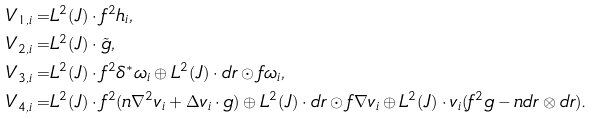Convert formula to latex. <formula><loc_0><loc_0><loc_500><loc_500>V _ { 1 , i } = & L ^ { 2 } ( J ) \cdot f ^ { 2 } h _ { i } , \\ V _ { 2 , i } = & L ^ { 2 } ( J ) \cdot \tilde { g } , \\ V _ { 3 , i } = & L ^ { 2 } ( J ) \cdot f ^ { 2 } \delta ^ { * } \omega _ { i } \oplus L ^ { 2 } ( J ) \cdot d r \odot f \omega _ { i } , \\ V _ { 4 , i } = & L ^ { 2 } ( J ) \cdot f ^ { 2 } ( n \nabla ^ { 2 } v _ { i } + \Delta v _ { i } \cdot g ) \oplus L ^ { 2 } ( J ) \cdot d r \odot f \nabla v _ { i } \oplus L ^ { 2 } ( J ) \cdot v _ { i } ( f ^ { 2 } g - n d r \otimes d r ) .</formula> 